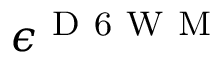<formula> <loc_0><loc_0><loc_500><loc_500>\epsilon ^ { D 6 W M }</formula> 